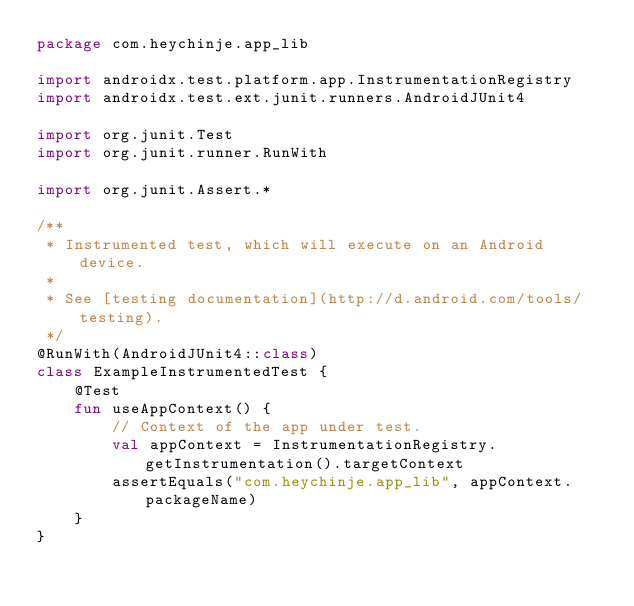<code> <loc_0><loc_0><loc_500><loc_500><_Kotlin_>package com.heychinje.app_lib

import androidx.test.platform.app.InstrumentationRegistry
import androidx.test.ext.junit.runners.AndroidJUnit4

import org.junit.Test
import org.junit.runner.RunWith

import org.junit.Assert.*

/**
 * Instrumented test, which will execute on an Android device.
 *
 * See [testing documentation](http://d.android.com/tools/testing).
 */
@RunWith(AndroidJUnit4::class)
class ExampleInstrumentedTest {
    @Test
    fun useAppContext() {
        // Context of the app under test.
        val appContext = InstrumentationRegistry.getInstrumentation().targetContext
        assertEquals("com.heychinje.app_lib", appContext.packageName)
    }
}</code> 